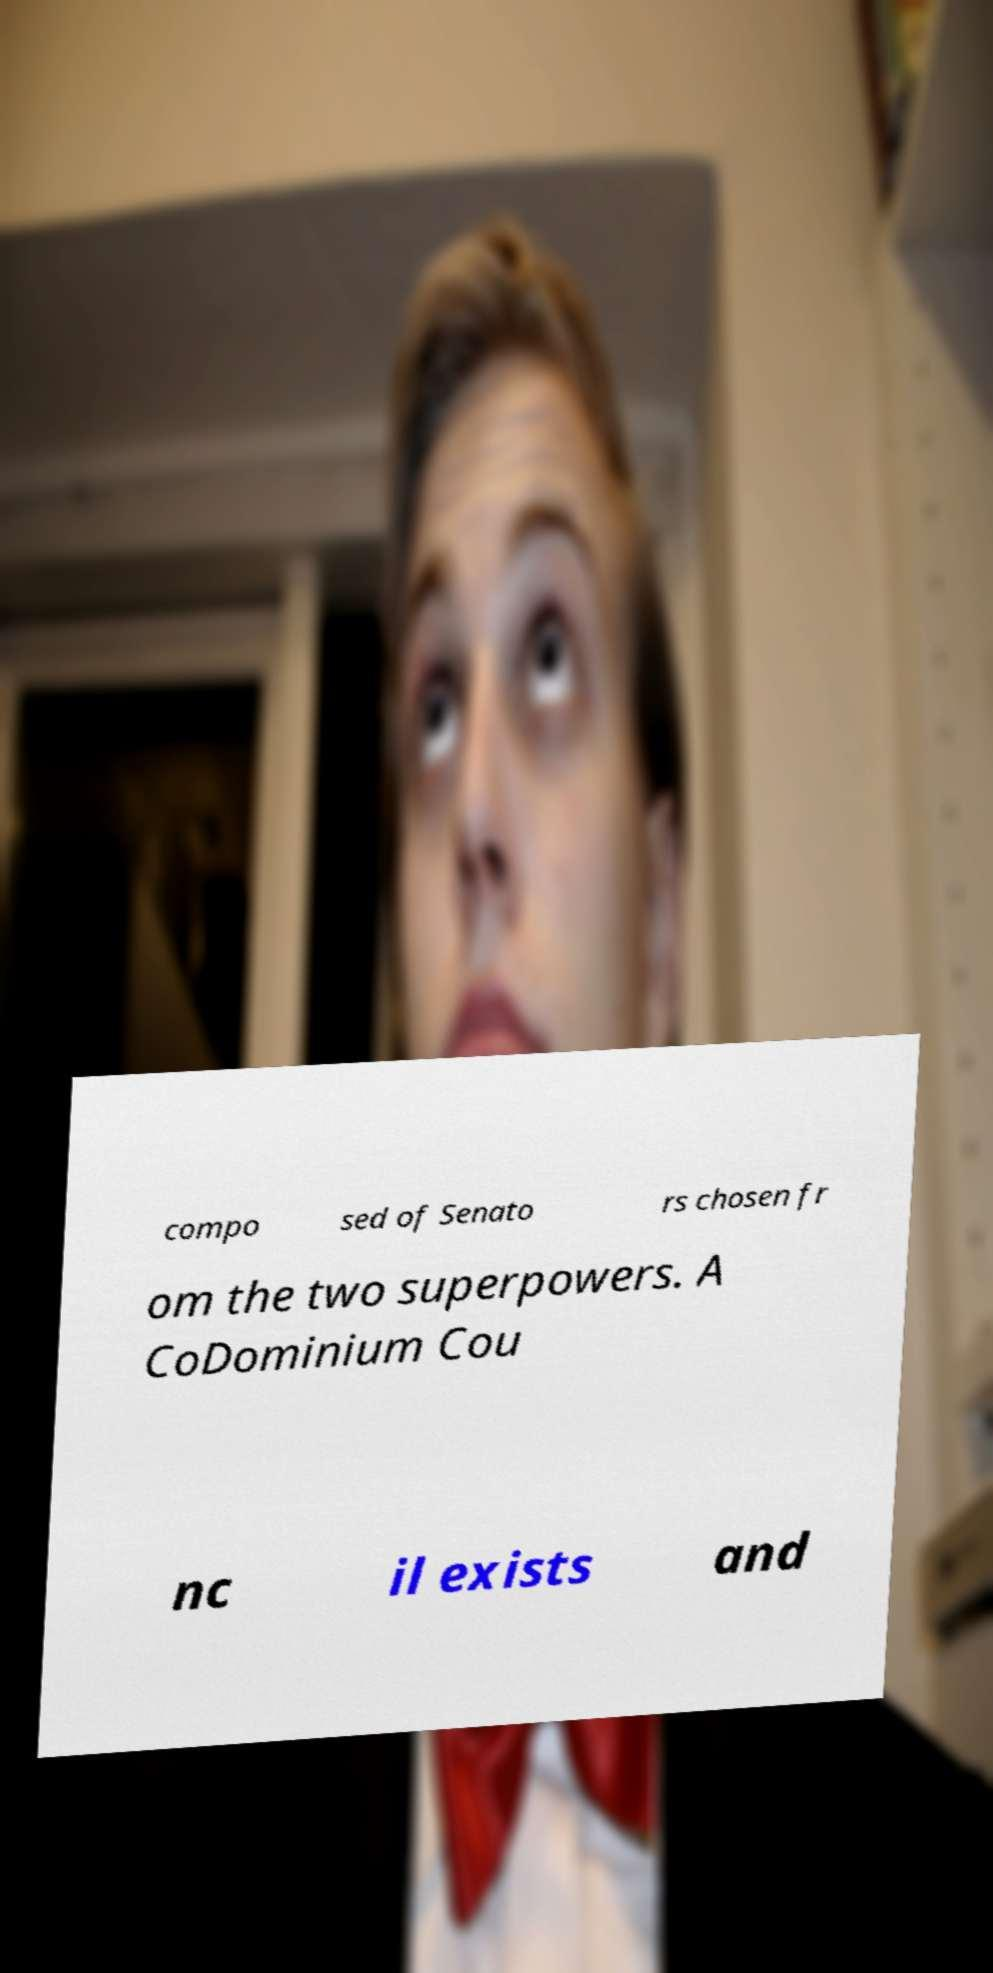Can you read and provide the text displayed in the image?This photo seems to have some interesting text. Can you extract and type it out for me? compo sed of Senato rs chosen fr om the two superpowers. A CoDominium Cou nc il exists and 